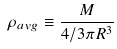<formula> <loc_0><loc_0><loc_500><loc_500>\rho _ { a v g } \equiv \frac { M } { 4 / 3 \pi R ^ { 3 } }</formula> 